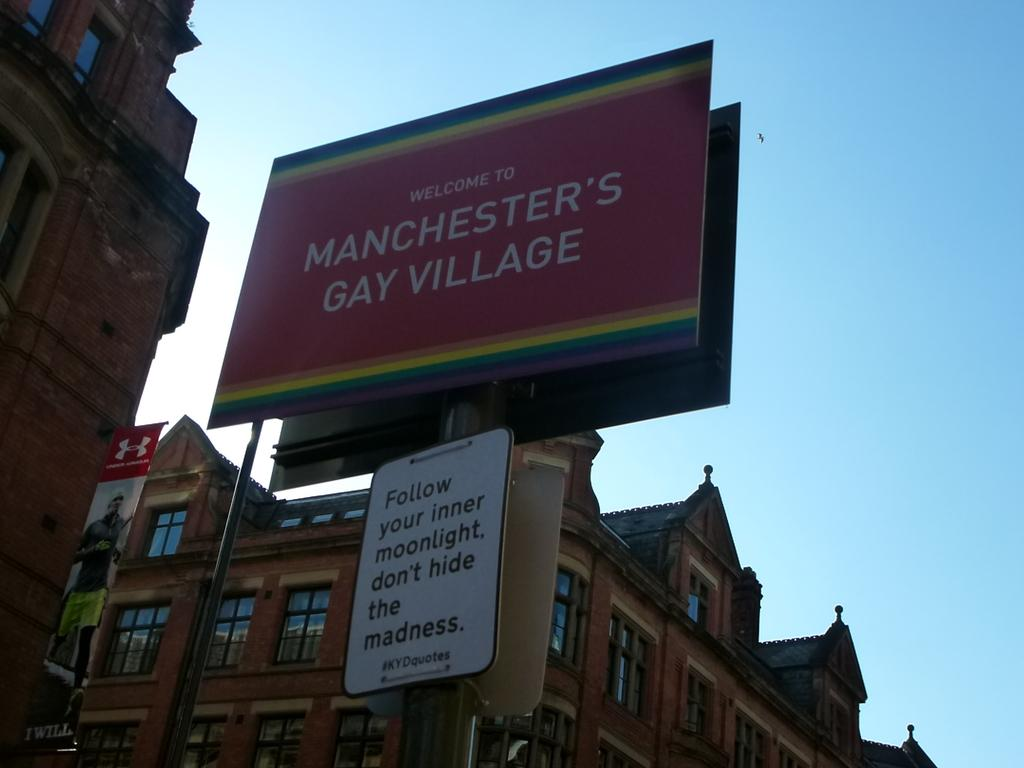<image>
Give a short and clear explanation of the subsequent image. A large sign on a building says Winchester's Gay Village. 